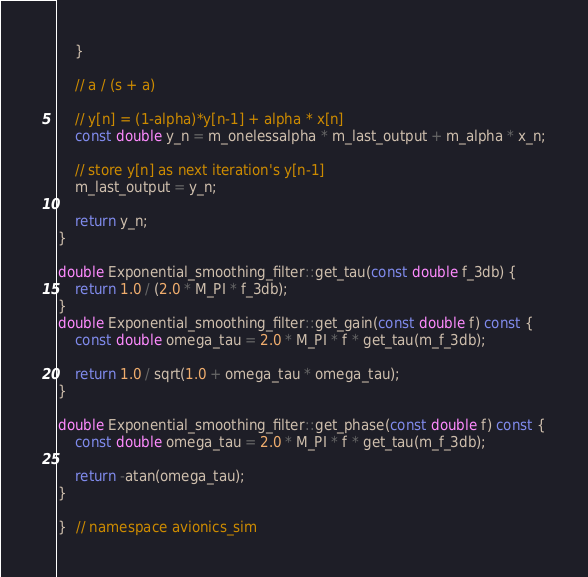<code> <loc_0><loc_0><loc_500><loc_500><_C++_>    }

    // a / (s + a)

    // y[n] = (1-alpha)*y[n-1] + alpha * x[n]
    const double y_n = m_onelessalpha * m_last_output + m_alpha * x_n;

    // store y[n] as next iteration's y[n-1]
    m_last_output = y_n;

    return y_n;
}

double Exponential_smoothing_filter::get_tau(const double f_3db) {
    return 1.0 / (2.0 * M_PI * f_3db);
}
double Exponential_smoothing_filter::get_gain(const double f) const {
    const double omega_tau = 2.0 * M_PI * f * get_tau(m_f_3db);

    return 1.0 / sqrt(1.0 + omega_tau * omega_tau);
}

double Exponential_smoothing_filter::get_phase(const double f) const {
    const double omega_tau = 2.0 * M_PI * f * get_tau(m_f_3db);

    return -atan(omega_tau);
}

}  // namespace avionics_sim
</code> 